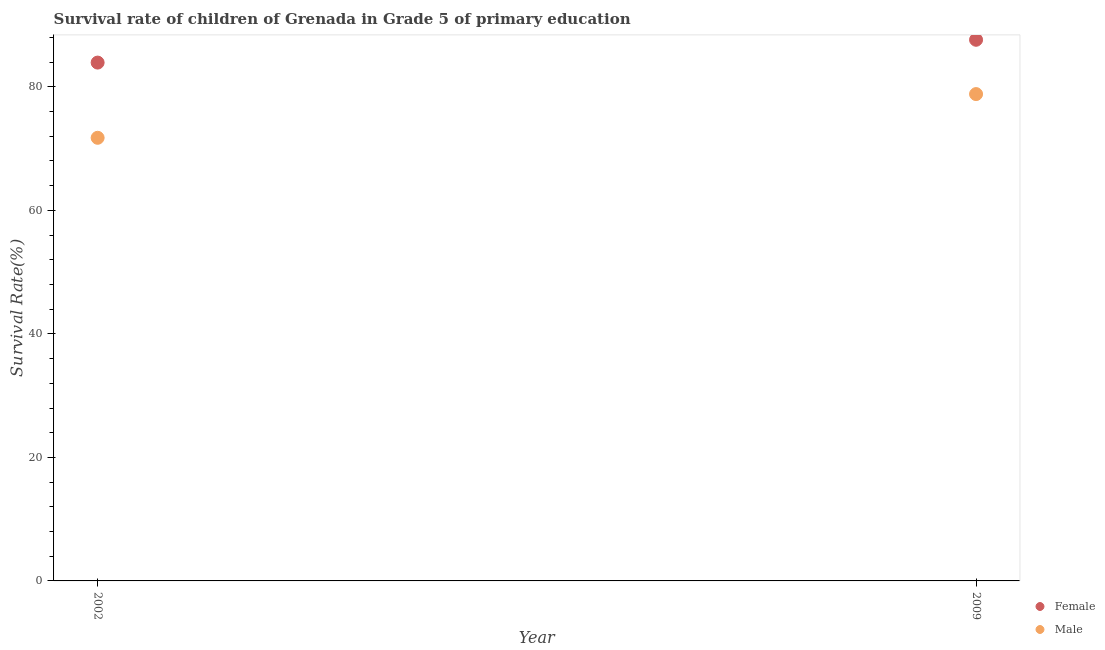How many different coloured dotlines are there?
Your answer should be compact. 2. Is the number of dotlines equal to the number of legend labels?
Provide a short and direct response. Yes. What is the survival rate of female students in primary education in 2002?
Offer a terse response. 83.93. Across all years, what is the maximum survival rate of female students in primary education?
Provide a short and direct response. 87.63. Across all years, what is the minimum survival rate of male students in primary education?
Your response must be concise. 71.76. In which year was the survival rate of male students in primary education minimum?
Your answer should be compact. 2002. What is the total survival rate of male students in primary education in the graph?
Give a very brief answer. 150.59. What is the difference between the survival rate of female students in primary education in 2002 and that in 2009?
Your answer should be very brief. -3.69. What is the difference between the survival rate of male students in primary education in 2002 and the survival rate of female students in primary education in 2009?
Offer a terse response. -15.87. What is the average survival rate of female students in primary education per year?
Keep it short and to the point. 85.78. In the year 2009, what is the difference between the survival rate of female students in primary education and survival rate of male students in primary education?
Give a very brief answer. 8.79. What is the ratio of the survival rate of male students in primary education in 2002 to that in 2009?
Give a very brief answer. 0.91. Is the survival rate of female students in primary education strictly greater than the survival rate of male students in primary education over the years?
Give a very brief answer. Yes. How many dotlines are there?
Keep it short and to the point. 2. How many years are there in the graph?
Give a very brief answer. 2. What is the difference between two consecutive major ticks on the Y-axis?
Your answer should be compact. 20. How are the legend labels stacked?
Offer a very short reply. Vertical. What is the title of the graph?
Offer a very short reply. Survival rate of children of Grenada in Grade 5 of primary education. What is the label or title of the X-axis?
Your answer should be compact. Year. What is the label or title of the Y-axis?
Make the answer very short. Survival Rate(%). What is the Survival Rate(%) in Female in 2002?
Your answer should be compact. 83.93. What is the Survival Rate(%) of Male in 2002?
Your answer should be compact. 71.76. What is the Survival Rate(%) in Female in 2009?
Your answer should be compact. 87.63. What is the Survival Rate(%) in Male in 2009?
Your response must be concise. 78.83. Across all years, what is the maximum Survival Rate(%) of Female?
Make the answer very short. 87.63. Across all years, what is the maximum Survival Rate(%) in Male?
Ensure brevity in your answer.  78.83. Across all years, what is the minimum Survival Rate(%) in Female?
Make the answer very short. 83.93. Across all years, what is the minimum Survival Rate(%) in Male?
Make the answer very short. 71.76. What is the total Survival Rate(%) in Female in the graph?
Ensure brevity in your answer.  171.56. What is the total Survival Rate(%) in Male in the graph?
Your answer should be compact. 150.59. What is the difference between the Survival Rate(%) of Female in 2002 and that in 2009?
Offer a terse response. -3.69. What is the difference between the Survival Rate(%) in Male in 2002 and that in 2009?
Your response must be concise. -7.08. What is the difference between the Survival Rate(%) of Female in 2002 and the Survival Rate(%) of Male in 2009?
Provide a succinct answer. 5.1. What is the average Survival Rate(%) of Female per year?
Give a very brief answer. 85.78. What is the average Survival Rate(%) in Male per year?
Provide a succinct answer. 75.29. In the year 2002, what is the difference between the Survival Rate(%) in Female and Survival Rate(%) in Male?
Your answer should be compact. 12.18. In the year 2009, what is the difference between the Survival Rate(%) of Female and Survival Rate(%) of Male?
Your answer should be compact. 8.79. What is the ratio of the Survival Rate(%) in Female in 2002 to that in 2009?
Provide a succinct answer. 0.96. What is the ratio of the Survival Rate(%) in Male in 2002 to that in 2009?
Provide a succinct answer. 0.91. What is the difference between the highest and the second highest Survival Rate(%) of Female?
Make the answer very short. 3.69. What is the difference between the highest and the second highest Survival Rate(%) in Male?
Your answer should be very brief. 7.08. What is the difference between the highest and the lowest Survival Rate(%) in Female?
Your response must be concise. 3.69. What is the difference between the highest and the lowest Survival Rate(%) of Male?
Your response must be concise. 7.08. 